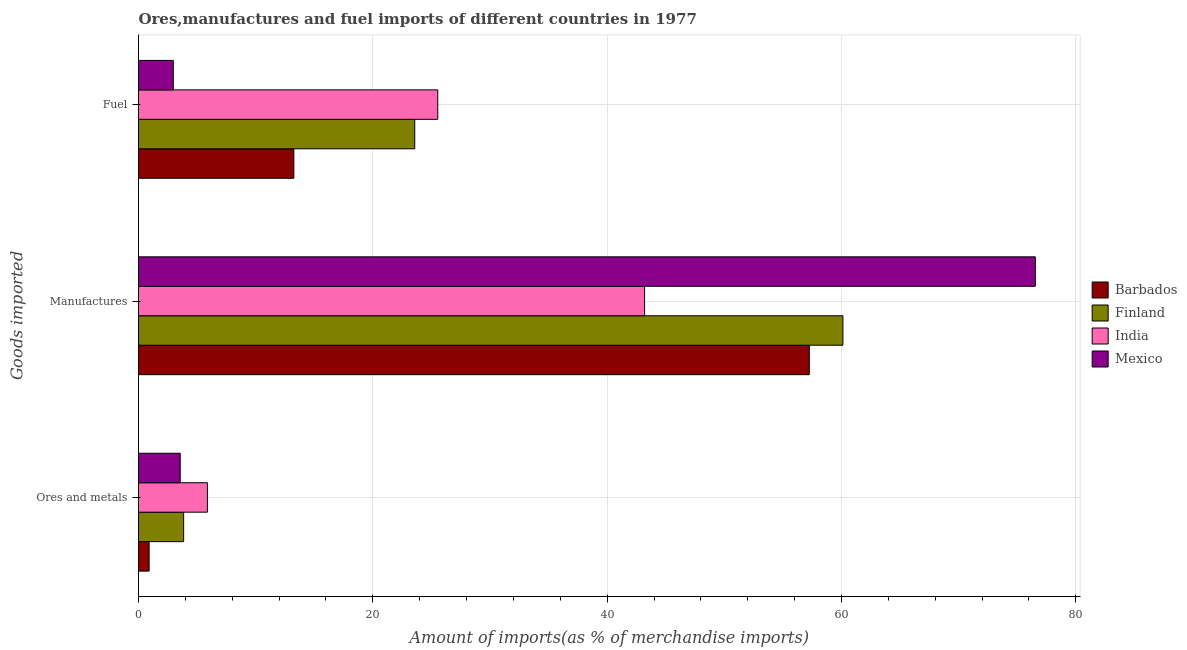How many different coloured bars are there?
Ensure brevity in your answer.  4. How many groups of bars are there?
Keep it short and to the point. 3. Are the number of bars on each tick of the Y-axis equal?
Give a very brief answer. Yes. How many bars are there on the 3rd tick from the top?
Provide a short and direct response. 4. What is the label of the 2nd group of bars from the top?
Your answer should be compact. Manufactures. What is the percentage of ores and metals imports in India?
Offer a terse response. 5.88. Across all countries, what is the maximum percentage of manufactures imports?
Keep it short and to the point. 76.54. Across all countries, what is the minimum percentage of fuel imports?
Provide a short and direct response. 2.97. In which country was the percentage of manufactures imports maximum?
Your answer should be compact. Mexico. In which country was the percentage of fuel imports minimum?
Your answer should be compact. Mexico. What is the total percentage of manufactures imports in the graph?
Your response must be concise. 237.1. What is the difference between the percentage of ores and metals imports in Barbados and that in Finland?
Ensure brevity in your answer.  -2.95. What is the difference between the percentage of manufactures imports in Barbados and the percentage of fuel imports in Mexico?
Provide a short and direct response. 54.28. What is the average percentage of fuel imports per country?
Ensure brevity in your answer.  16.34. What is the difference between the percentage of manufactures imports and percentage of fuel imports in Barbados?
Make the answer very short. 43.99. In how many countries, is the percentage of fuel imports greater than 64 %?
Offer a very short reply. 0. What is the ratio of the percentage of ores and metals imports in Mexico to that in India?
Your response must be concise. 0.61. Is the percentage of ores and metals imports in Finland less than that in Mexico?
Ensure brevity in your answer.  No. Is the difference between the percentage of ores and metals imports in India and Barbados greater than the difference between the percentage of manufactures imports in India and Barbados?
Offer a terse response. Yes. What is the difference between the highest and the second highest percentage of ores and metals imports?
Make the answer very short. 2.03. What is the difference between the highest and the lowest percentage of fuel imports?
Provide a short and direct response. 22.57. Is the sum of the percentage of manufactures imports in Mexico and Finland greater than the maximum percentage of ores and metals imports across all countries?
Give a very brief answer. Yes. Is it the case that in every country, the sum of the percentage of ores and metals imports and percentage of manufactures imports is greater than the percentage of fuel imports?
Give a very brief answer. Yes. How many bars are there?
Your answer should be very brief. 12. Are all the bars in the graph horizontal?
Your answer should be very brief. Yes. What is the difference between two consecutive major ticks on the X-axis?
Your answer should be compact. 20. Does the graph contain any zero values?
Provide a succinct answer. No. Does the graph contain grids?
Your answer should be very brief. Yes. How many legend labels are there?
Provide a short and direct response. 4. How are the legend labels stacked?
Provide a succinct answer. Vertical. What is the title of the graph?
Keep it short and to the point. Ores,manufactures and fuel imports of different countries in 1977. What is the label or title of the X-axis?
Provide a short and direct response. Amount of imports(as % of merchandise imports). What is the label or title of the Y-axis?
Your response must be concise. Goods imported. What is the Amount of imports(as % of merchandise imports) of Barbados in Ores and metals?
Offer a terse response. 0.91. What is the Amount of imports(as % of merchandise imports) in Finland in Ores and metals?
Keep it short and to the point. 3.85. What is the Amount of imports(as % of merchandise imports) of India in Ores and metals?
Provide a short and direct response. 5.88. What is the Amount of imports(as % of merchandise imports) of Mexico in Ores and metals?
Offer a very short reply. 3.56. What is the Amount of imports(as % of merchandise imports) in Barbados in Manufactures?
Give a very brief answer. 57.25. What is the Amount of imports(as % of merchandise imports) of Finland in Manufactures?
Offer a terse response. 60.12. What is the Amount of imports(as % of merchandise imports) of India in Manufactures?
Make the answer very short. 43.19. What is the Amount of imports(as % of merchandise imports) in Mexico in Manufactures?
Offer a terse response. 76.54. What is the Amount of imports(as % of merchandise imports) of Barbados in Fuel?
Provide a succinct answer. 13.26. What is the Amount of imports(as % of merchandise imports) in Finland in Fuel?
Offer a very short reply. 23.58. What is the Amount of imports(as % of merchandise imports) of India in Fuel?
Your answer should be very brief. 25.54. What is the Amount of imports(as % of merchandise imports) of Mexico in Fuel?
Your response must be concise. 2.97. Across all Goods imported, what is the maximum Amount of imports(as % of merchandise imports) in Barbados?
Make the answer very short. 57.25. Across all Goods imported, what is the maximum Amount of imports(as % of merchandise imports) of Finland?
Provide a short and direct response. 60.12. Across all Goods imported, what is the maximum Amount of imports(as % of merchandise imports) of India?
Keep it short and to the point. 43.19. Across all Goods imported, what is the maximum Amount of imports(as % of merchandise imports) of Mexico?
Your response must be concise. 76.54. Across all Goods imported, what is the minimum Amount of imports(as % of merchandise imports) of Barbados?
Give a very brief answer. 0.91. Across all Goods imported, what is the minimum Amount of imports(as % of merchandise imports) of Finland?
Provide a short and direct response. 3.85. Across all Goods imported, what is the minimum Amount of imports(as % of merchandise imports) in India?
Your response must be concise. 5.88. Across all Goods imported, what is the minimum Amount of imports(as % of merchandise imports) of Mexico?
Offer a very short reply. 2.97. What is the total Amount of imports(as % of merchandise imports) in Barbados in the graph?
Provide a succinct answer. 71.41. What is the total Amount of imports(as % of merchandise imports) of Finland in the graph?
Your answer should be very brief. 87.55. What is the total Amount of imports(as % of merchandise imports) in India in the graph?
Your answer should be compact. 74.61. What is the total Amount of imports(as % of merchandise imports) of Mexico in the graph?
Offer a terse response. 83.07. What is the difference between the Amount of imports(as % of merchandise imports) in Barbados in Ores and metals and that in Manufactures?
Make the answer very short. -56.34. What is the difference between the Amount of imports(as % of merchandise imports) in Finland in Ores and metals and that in Manufactures?
Ensure brevity in your answer.  -56.27. What is the difference between the Amount of imports(as % of merchandise imports) of India in Ores and metals and that in Manufactures?
Keep it short and to the point. -37.31. What is the difference between the Amount of imports(as % of merchandise imports) of Mexico in Ores and metals and that in Manufactures?
Provide a succinct answer. -72.98. What is the difference between the Amount of imports(as % of merchandise imports) in Barbados in Ores and metals and that in Fuel?
Your response must be concise. -12.35. What is the difference between the Amount of imports(as % of merchandise imports) in Finland in Ores and metals and that in Fuel?
Your answer should be very brief. -19.72. What is the difference between the Amount of imports(as % of merchandise imports) of India in Ores and metals and that in Fuel?
Provide a succinct answer. -19.66. What is the difference between the Amount of imports(as % of merchandise imports) of Mexico in Ores and metals and that in Fuel?
Your answer should be compact. 0.59. What is the difference between the Amount of imports(as % of merchandise imports) in Barbados in Manufactures and that in Fuel?
Give a very brief answer. 43.99. What is the difference between the Amount of imports(as % of merchandise imports) of Finland in Manufactures and that in Fuel?
Ensure brevity in your answer.  36.54. What is the difference between the Amount of imports(as % of merchandise imports) of India in Manufactures and that in Fuel?
Your answer should be very brief. 17.65. What is the difference between the Amount of imports(as % of merchandise imports) in Mexico in Manufactures and that in Fuel?
Ensure brevity in your answer.  73.57. What is the difference between the Amount of imports(as % of merchandise imports) in Barbados in Ores and metals and the Amount of imports(as % of merchandise imports) in Finland in Manufactures?
Provide a short and direct response. -59.21. What is the difference between the Amount of imports(as % of merchandise imports) of Barbados in Ores and metals and the Amount of imports(as % of merchandise imports) of India in Manufactures?
Offer a very short reply. -42.29. What is the difference between the Amount of imports(as % of merchandise imports) of Barbados in Ores and metals and the Amount of imports(as % of merchandise imports) of Mexico in Manufactures?
Provide a succinct answer. -75.63. What is the difference between the Amount of imports(as % of merchandise imports) of Finland in Ores and metals and the Amount of imports(as % of merchandise imports) of India in Manufactures?
Your response must be concise. -39.34. What is the difference between the Amount of imports(as % of merchandise imports) of Finland in Ores and metals and the Amount of imports(as % of merchandise imports) of Mexico in Manufactures?
Your response must be concise. -72.69. What is the difference between the Amount of imports(as % of merchandise imports) of India in Ores and metals and the Amount of imports(as % of merchandise imports) of Mexico in Manufactures?
Make the answer very short. -70.66. What is the difference between the Amount of imports(as % of merchandise imports) in Barbados in Ores and metals and the Amount of imports(as % of merchandise imports) in Finland in Fuel?
Ensure brevity in your answer.  -22.67. What is the difference between the Amount of imports(as % of merchandise imports) in Barbados in Ores and metals and the Amount of imports(as % of merchandise imports) in India in Fuel?
Your response must be concise. -24.63. What is the difference between the Amount of imports(as % of merchandise imports) of Barbados in Ores and metals and the Amount of imports(as % of merchandise imports) of Mexico in Fuel?
Provide a short and direct response. -2.06. What is the difference between the Amount of imports(as % of merchandise imports) of Finland in Ores and metals and the Amount of imports(as % of merchandise imports) of India in Fuel?
Your response must be concise. -21.69. What is the difference between the Amount of imports(as % of merchandise imports) in Finland in Ores and metals and the Amount of imports(as % of merchandise imports) in Mexico in Fuel?
Your response must be concise. 0.88. What is the difference between the Amount of imports(as % of merchandise imports) of India in Ores and metals and the Amount of imports(as % of merchandise imports) of Mexico in Fuel?
Provide a succinct answer. 2.91. What is the difference between the Amount of imports(as % of merchandise imports) in Barbados in Manufactures and the Amount of imports(as % of merchandise imports) in Finland in Fuel?
Offer a very short reply. 33.67. What is the difference between the Amount of imports(as % of merchandise imports) in Barbados in Manufactures and the Amount of imports(as % of merchandise imports) in India in Fuel?
Ensure brevity in your answer.  31.71. What is the difference between the Amount of imports(as % of merchandise imports) in Barbados in Manufactures and the Amount of imports(as % of merchandise imports) in Mexico in Fuel?
Offer a terse response. 54.28. What is the difference between the Amount of imports(as % of merchandise imports) in Finland in Manufactures and the Amount of imports(as % of merchandise imports) in India in Fuel?
Provide a succinct answer. 34.58. What is the difference between the Amount of imports(as % of merchandise imports) of Finland in Manufactures and the Amount of imports(as % of merchandise imports) of Mexico in Fuel?
Give a very brief answer. 57.15. What is the difference between the Amount of imports(as % of merchandise imports) in India in Manufactures and the Amount of imports(as % of merchandise imports) in Mexico in Fuel?
Keep it short and to the point. 40.22. What is the average Amount of imports(as % of merchandise imports) in Barbados per Goods imported?
Your answer should be compact. 23.8. What is the average Amount of imports(as % of merchandise imports) of Finland per Goods imported?
Keep it short and to the point. 29.18. What is the average Amount of imports(as % of merchandise imports) in India per Goods imported?
Your response must be concise. 24.87. What is the average Amount of imports(as % of merchandise imports) in Mexico per Goods imported?
Your answer should be compact. 27.69. What is the difference between the Amount of imports(as % of merchandise imports) in Barbados and Amount of imports(as % of merchandise imports) in Finland in Ores and metals?
Keep it short and to the point. -2.95. What is the difference between the Amount of imports(as % of merchandise imports) of Barbados and Amount of imports(as % of merchandise imports) of India in Ores and metals?
Ensure brevity in your answer.  -4.97. What is the difference between the Amount of imports(as % of merchandise imports) in Barbados and Amount of imports(as % of merchandise imports) in Mexico in Ores and metals?
Your response must be concise. -2.65. What is the difference between the Amount of imports(as % of merchandise imports) in Finland and Amount of imports(as % of merchandise imports) in India in Ores and metals?
Give a very brief answer. -2.03. What is the difference between the Amount of imports(as % of merchandise imports) in Finland and Amount of imports(as % of merchandise imports) in Mexico in Ores and metals?
Provide a succinct answer. 0.29. What is the difference between the Amount of imports(as % of merchandise imports) in India and Amount of imports(as % of merchandise imports) in Mexico in Ores and metals?
Your answer should be very brief. 2.32. What is the difference between the Amount of imports(as % of merchandise imports) in Barbados and Amount of imports(as % of merchandise imports) in Finland in Manufactures?
Provide a short and direct response. -2.87. What is the difference between the Amount of imports(as % of merchandise imports) in Barbados and Amount of imports(as % of merchandise imports) in India in Manufactures?
Provide a short and direct response. 14.06. What is the difference between the Amount of imports(as % of merchandise imports) of Barbados and Amount of imports(as % of merchandise imports) of Mexico in Manufactures?
Keep it short and to the point. -19.29. What is the difference between the Amount of imports(as % of merchandise imports) of Finland and Amount of imports(as % of merchandise imports) of India in Manufactures?
Keep it short and to the point. 16.93. What is the difference between the Amount of imports(as % of merchandise imports) of Finland and Amount of imports(as % of merchandise imports) of Mexico in Manufactures?
Provide a short and direct response. -16.42. What is the difference between the Amount of imports(as % of merchandise imports) in India and Amount of imports(as % of merchandise imports) in Mexico in Manufactures?
Your answer should be compact. -33.35. What is the difference between the Amount of imports(as % of merchandise imports) in Barbados and Amount of imports(as % of merchandise imports) in Finland in Fuel?
Your answer should be compact. -10.32. What is the difference between the Amount of imports(as % of merchandise imports) in Barbados and Amount of imports(as % of merchandise imports) in India in Fuel?
Offer a very short reply. -12.28. What is the difference between the Amount of imports(as % of merchandise imports) in Barbados and Amount of imports(as % of merchandise imports) in Mexico in Fuel?
Your response must be concise. 10.29. What is the difference between the Amount of imports(as % of merchandise imports) in Finland and Amount of imports(as % of merchandise imports) in India in Fuel?
Your response must be concise. -1.96. What is the difference between the Amount of imports(as % of merchandise imports) of Finland and Amount of imports(as % of merchandise imports) of Mexico in Fuel?
Offer a very short reply. 20.61. What is the difference between the Amount of imports(as % of merchandise imports) of India and Amount of imports(as % of merchandise imports) of Mexico in Fuel?
Your response must be concise. 22.57. What is the ratio of the Amount of imports(as % of merchandise imports) in Barbados in Ores and metals to that in Manufactures?
Give a very brief answer. 0.02. What is the ratio of the Amount of imports(as % of merchandise imports) in Finland in Ores and metals to that in Manufactures?
Your response must be concise. 0.06. What is the ratio of the Amount of imports(as % of merchandise imports) of India in Ores and metals to that in Manufactures?
Your answer should be compact. 0.14. What is the ratio of the Amount of imports(as % of merchandise imports) of Mexico in Ores and metals to that in Manufactures?
Offer a terse response. 0.05. What is the ratio of the Amount of imports(as % of merchandise imports) of Barbados in Ores and metals to that in Fuel?
Your response must be concise. 0.07. What is the ratio of the Amount of imports(as % of merchandise imports) in Finland in Ores and metals to that in Fuel?
Give a very brief answer. 0.16. What is the ratio of the Amount of imports(as % of merchandise imports) in India in Ores and metals to that in Fuel?
Make the answer very short. 0.23. What is the ratio of the Amount of imports(as % of merchandise imports) of Mexico in Ores and metals to that in Fuel?
Offer a very short reply. 1.2. What is the ratio of the Amount of imports(as % of merchandise imports) of Barbados in Manufactures to that in Fuel?
Ensure brevity in your answer.  4.32. What is the ratio of the Amount of imports(as % of merchandise imports) of Finland in Manufactures to that in Fuel?
Ensure brevity in your answer.  2.55. What is the ratio of the Amount of imports(as % of merchandise imports) in India in Manufactures to that in Fuel?
Give a very brief answer. 1.69. What is the ratio of the Amount of imports(as % of merchandise imports) in Mexico in Manufactures to that in Fuel?
Give a very brief answer. 25.77. What is the difference between the highest and the second highest Amount of imports(as % of merchandise imports) in Barbados?
Your answer should be compact. 43.99. What is the difference between the highest and the second highest Amount of imports(as % of merchandise imports) in Finland?
Offer a terse response. 36.54. What is the difference between the highest and the second highest Amount of imports(as % of merchandise imports) of India?
Your response must be concise. 17.65. What is the difference between the highest and the second highest Amount of imports(as % of merchandise imports) in Mexico?
Your answer should be compact. 72.98. What is the difference between the highest and the lowest Amount of imports(as % of merchandise imports) in Barbados?
Make the answer very short. 56.34. What is the difference between the highest and the lowest Amount of imports(as % of merchandise imports) of Finland?
Your answer should be compact. 56.27. What is the difference between the highest and the lowest Amount of imports(as % of merchandise imports) of India?
Offer a terse response. 37.31. What is the difference between the highest and the lowest Amount of imports(as % of merchandise imports) in Mexico?
Your answer should be very brief. 73.57. 